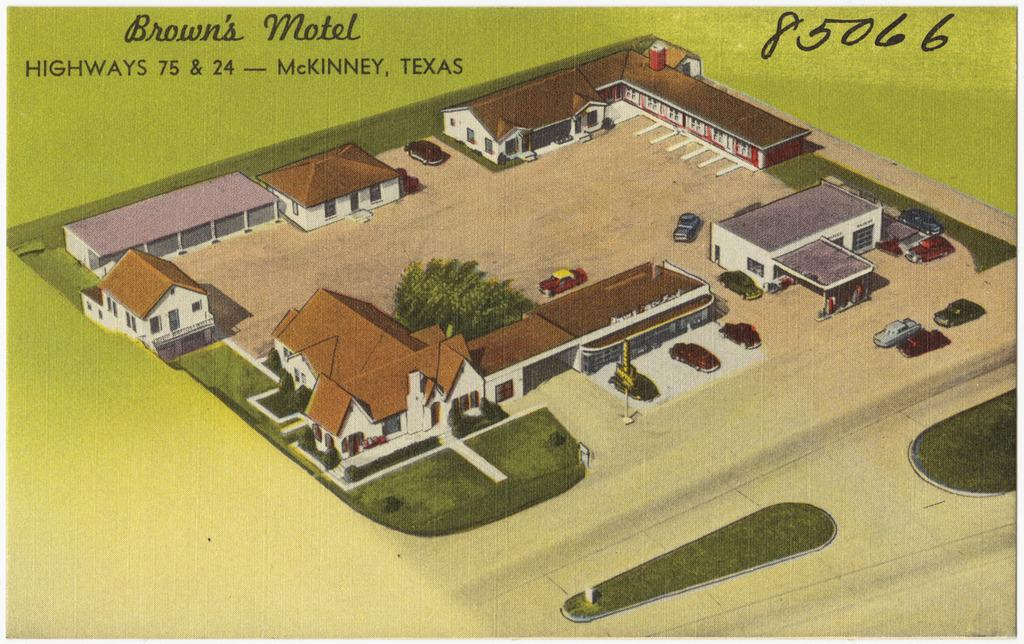What type of structures are depicted in the image? There are depictions of buildings in the image. What type of vegetation is present in the image? There are trees in the image. What type of vehicles can be seen in the image? There are cars in the image. What type of ground cover is present in the image? There is grass in the image. What is written or displayed at the top of the image? There is some text on the top of the image. What type of care is being provided to the trees in the image? There is no indication of any care being provided to the trees in the image; they are simply depicted as part of the scene. What type of air is being circulated in the image? There is no information about air circulation in the image; it is a static representation of the scene. 